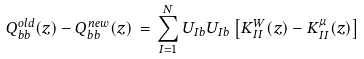<formula> <loc_0><loc_0><loc_500><loc_500>Q ^ { o l d } _ { b b } ( z ) - Q ^ { n e w } _ { b b } ( z ) \, = \, \sum _ { I = 1 } ^ { N } U _ { I b } U _ { I b } \left [ K ^ { W } _ { I I } ( z ) - K ^ { \mu } _ { I I } ( z ) \right ]</formula> 